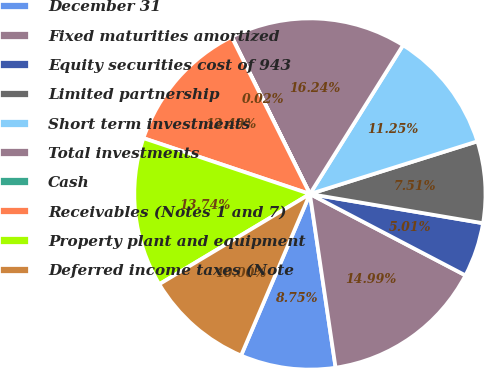Convert chart. <chart><loc_0><loc_0><loc_500><loc_500><pie_chart><fcel>December 31<fcel>Fixed maturities amortized<fcel>Equity securities cost of 943<fcel>Limited partnership<fcel>Short term investments<fcel>Total investments<fcel>Cash<fcel>Receivables (Notes 1 and 7)<fcel>Property plant and equipment<fcel>Deferred income taxes (Note<nl><fcel>8.75%<fcel>14.99%<fcel>5.01%<fcel>7.51%<fcel>11.25%<fcel>16.24%<fcel>0.02%<fcel>12.49%<fcel>13.74%<fcel>10.0%<nl></chart> 